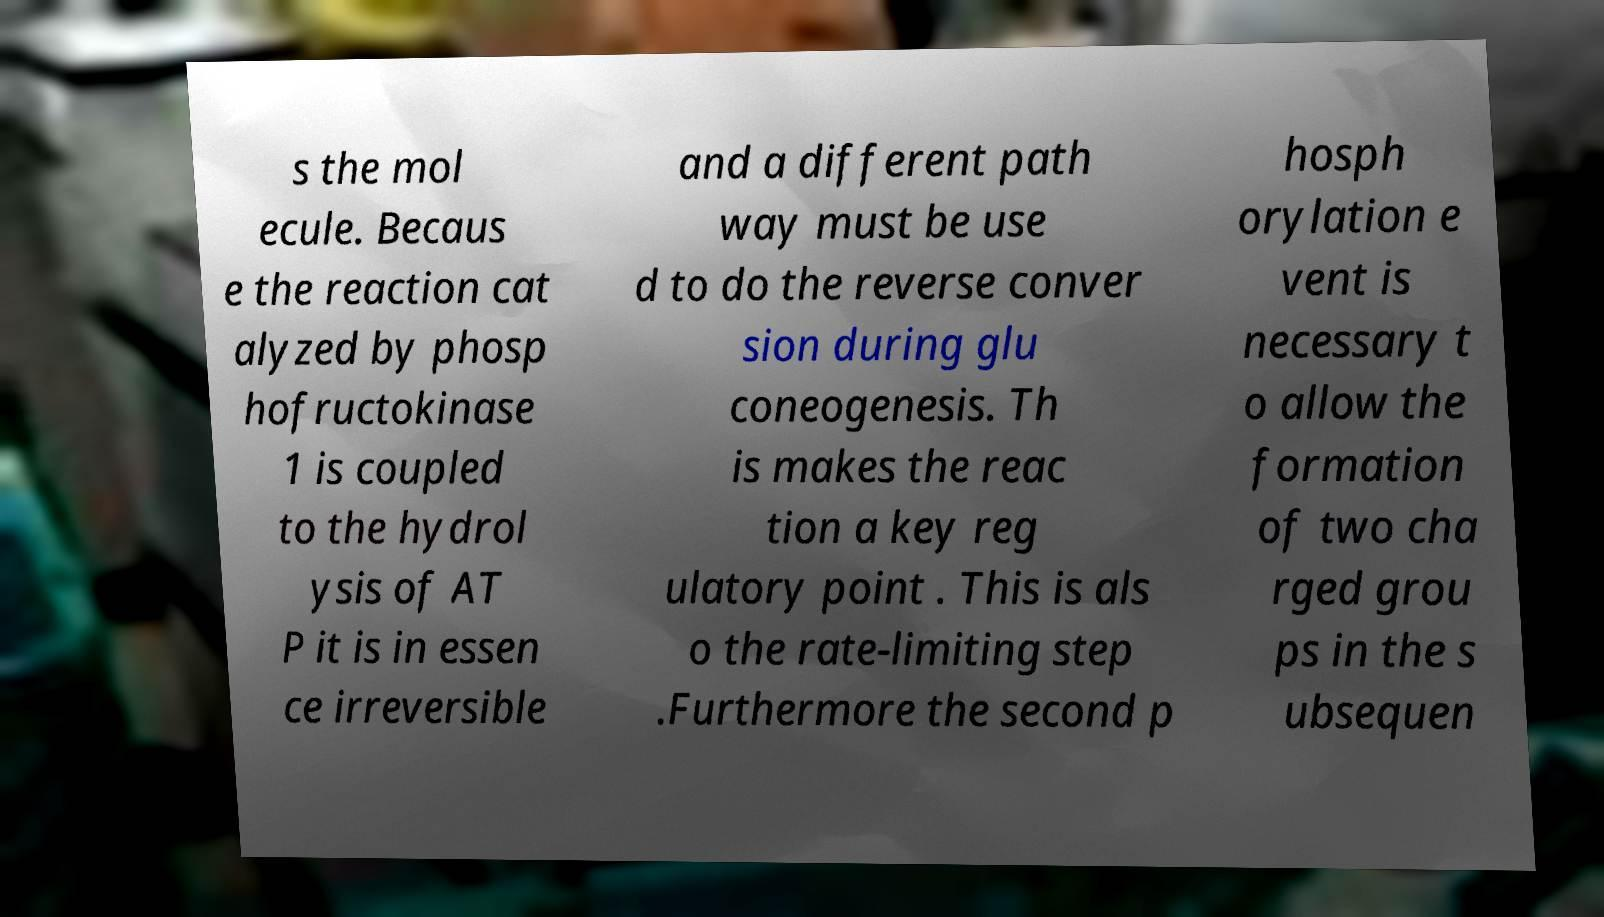What messages or text are displayed in this image? I need them in a readable, typed format. s the mol ecule. Becaus e the reaction cat alyzed by phosp hofructokinase 1 is coupled to the hydrol ysis of AT P it is in essen ce irreversible and a different path way must be use d to do the reverse conver sion during glu coneogenesis. Th is makes the reac tion a key reg ulatory point . This is als o the rate-limiting step .Furthermore the second p hosph orylation e vent is necessary t o allow the formation of two cha rged grou ps in the s ubsequen 